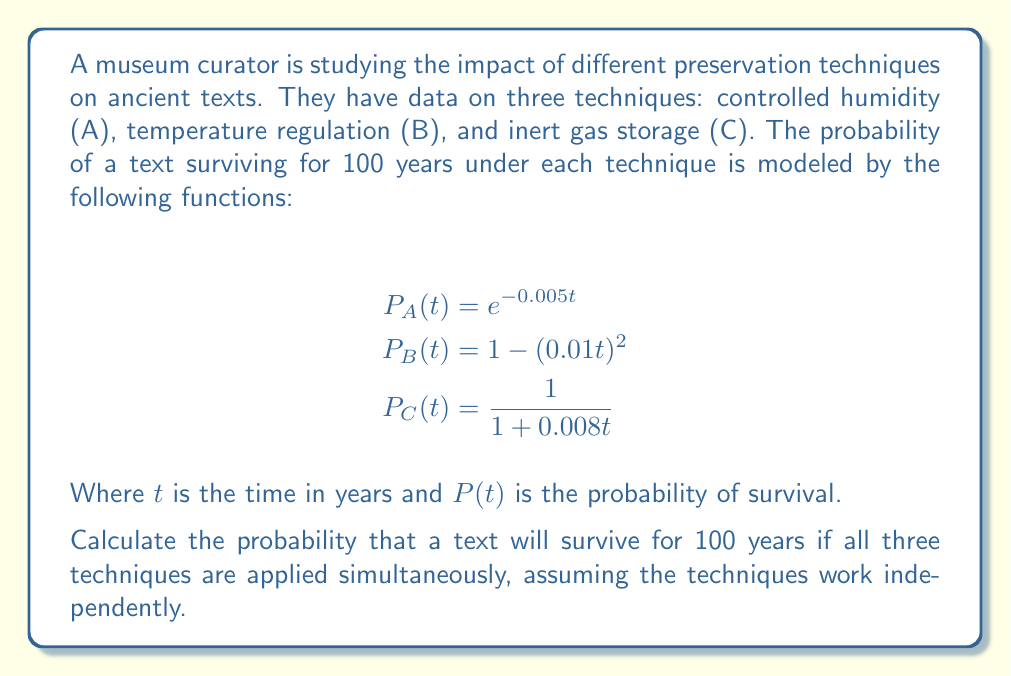Can you answer this question? To solve this problem, we need to follow these steps:

1. Calculate the probability of survival for each technique at $t = 100$ years.
2. Since the techniques are independent, multiply the individual probabilities to get the combined probability.

Step 1: Calculate individual probabilities

For technique A:
$P_A(100) = e^{-0.005 \cdot 100} = e^{-0.5} \approx 0.6065$

For technique B:
$P_B(100) = 1 - (0.01 \cdot 100)^2 = 1 - 1^2 = 0$

For technique C:
$P_C(100) = \frac{1}{1 + 0.008 \cdot 100} = \frac{1}{1.8} \approx 0.5556$

Step 2: Multiply the individual probabilities

The probability of survival using all three techniques is:

$P_{total} = P_A(100) \cdot P_B(100) \cdot P_C(100)$

$P_{total} = 0.6065 \cdot 0 \cdot 0.5556 = 0$

The result is 0 because technique B has a 0% chance of preserving the text for 100 years according to the given model.
Answer: 0 